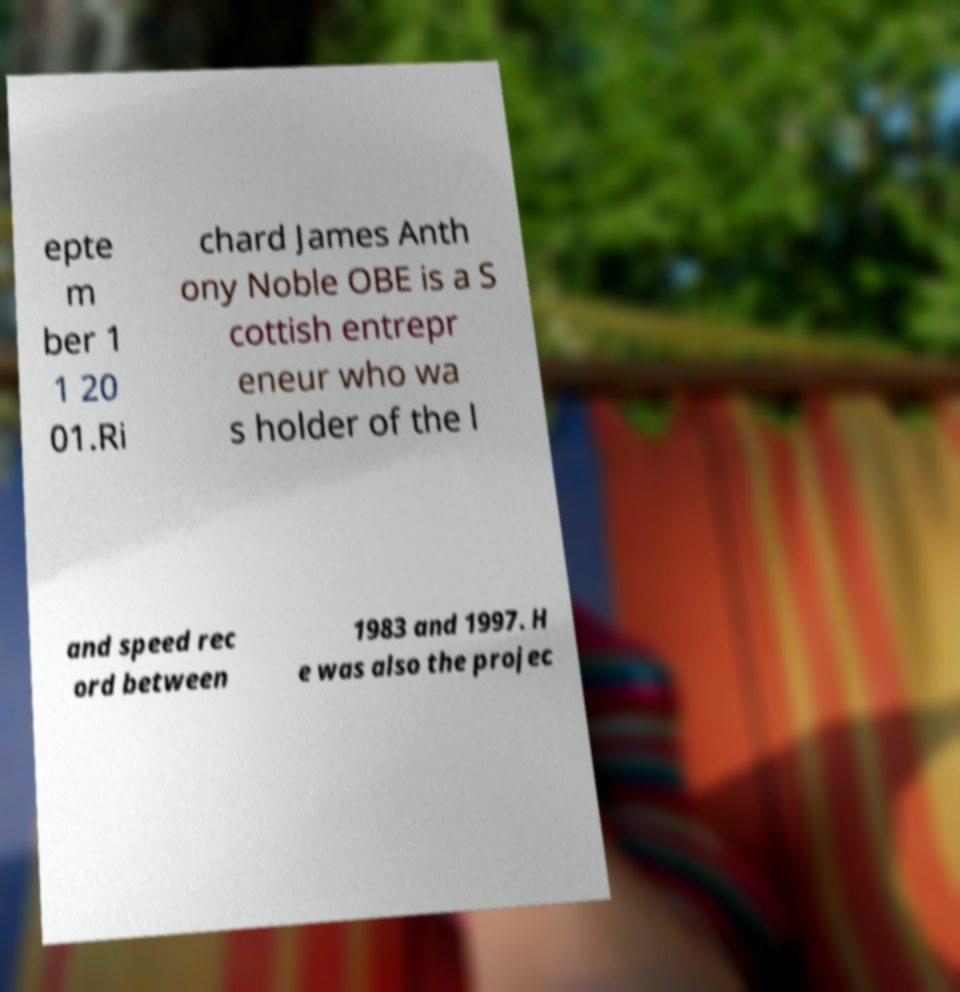Can you read and provide the text displayed in the image?This photo seems to have some interesting text. Can you extract and type it out for me? epte m ber 1 1 20 01.Ri chard James Anth ony Noble OBE is a S cottish entrepr eneur who wa s holder of the l and speed rec ord between 1983 and 1997. H e was also the projec 